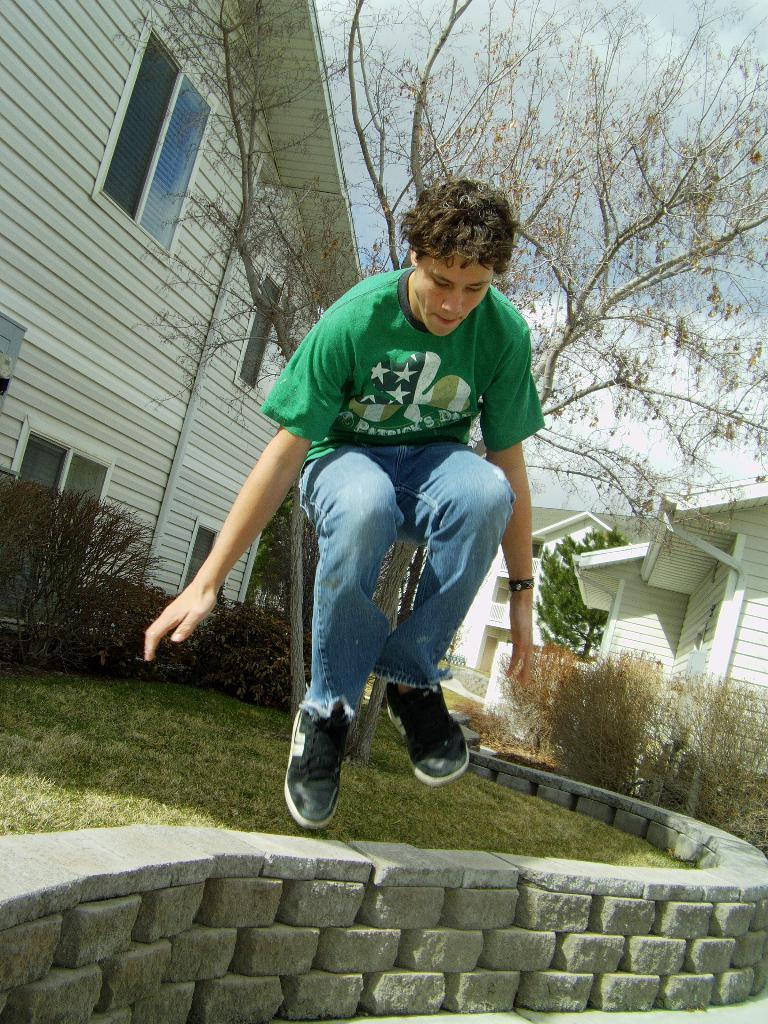What is the man in the image wearing? The man is wearing a green T-shirt in the image. What is the man doing in the image? The man is humping in the image. What type of structures can be seen in the image? There are houses and a small wall in the image. What type of vegetation is present in the image? There are trees, plants, and grass in the image. What is visible at the top of the image? The sky is visible at the top of the image, and it is cloudy. What letters can be seen on the roof of the houses in the image? There are no letters visible on the roofs of the houses in the image. What is the chance of winning a lottery in the image? There is no reference to a lottery or any chances in the image. 